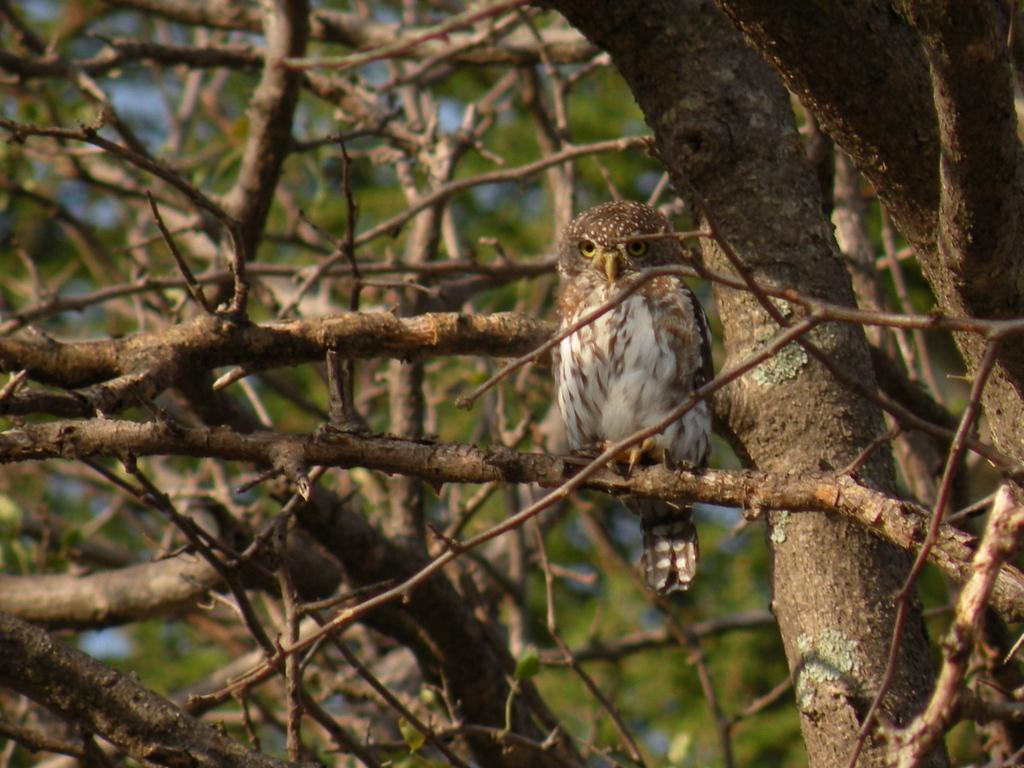What animal is present in the image? There is an owl in the image. Where is the owl located? The owl is standing on a branch of a tree. How many branches of the tree are visible in the image? There are multiple branches of the tree visible in the image. What is the color of the background in the image? The background of the image is green in color. What type of drink is the owl holding in its talons? The owl is not holding any drink in its talons; it is standing on a branch of a tree. 